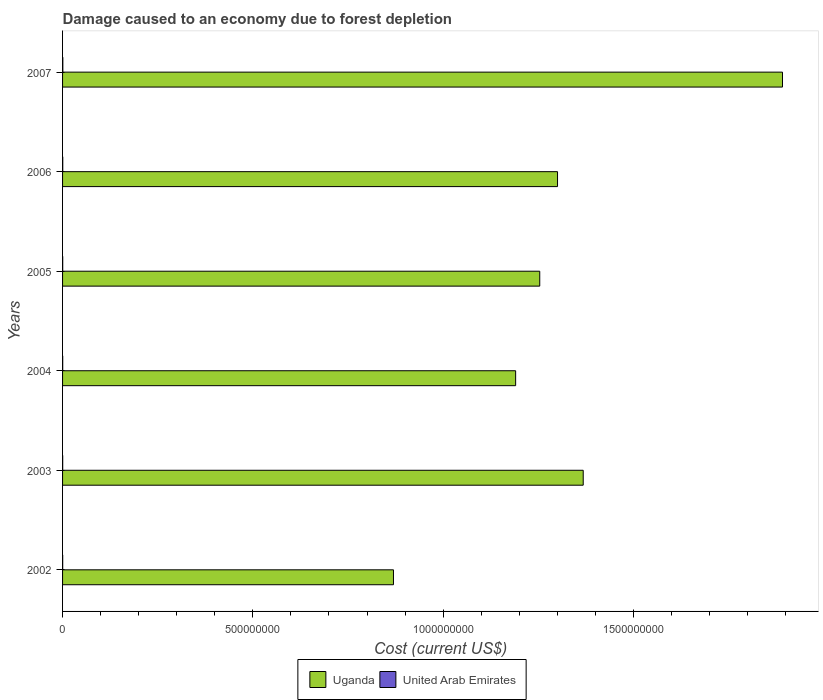How many different coloured bars are there?
Provide a succinct answer. 2. Are the number of bars per tick equal to the number of legend labels?
Keep it short and to the point. Yes. How many bars are there on the 6th tick from the bottom?
Offer a very short reply. 2. What is the label of the 6th group of bars from the top?
Keep it short and to the point. 2002. In how many cases, is the number of bars for a given year not equal to the number of legend labels?
Provide a short and direct response. 0. What is the cost of damage caused due to forest depletion in Uganda in 2005?
Your response must be concise. 1.25e+09. Across all years, what is the maximum cost of damage caused due to forest depletion in United Arab Emirates?
Ensure brevity in your answer.  6.81e+05. Across all years, what is the minimum cost of damage caused due to forest depletion in United Arab Emirates?
Your response must be concise. 3.08e+05. In which year was the cost of damage caused due to forest depletion in Uganda minimum?
Offer a terse response. 2002. What is the total cost of damage caused due to forest depletion in United Arab Emirates in the graph?
Provide a short and direct response. 2.56e+06. What is the difference between the cost of damage caused due to forest depletion in Uganda in 2003 and that in 2007?
Provide a succinct answer. -5.24e+08. What is the difference between the cost of damage caused due to forest depletion in United Arab Emirates in 2006 and the cost of damage caused due to forest depletion in Uganda in 2005?
Offer a very short reply. -1.25e+09. What is the average cost of damage caused due to forest depletion in Uganda per year?
Ensure brevity in your answer.  1.31e+09. In the year 2002, what is the difference between the cost of damage caused due to forest depletion in Uganda and cost of damage caused due to forest depletion in United Arab Emirates?
Make the answer very short. 8.69e+08. What is the ratio of the cost of damage caused due to forest depletion in United Arab Emirates in 2005 to that in 2007?
Offer a terse response. 0.56. Is the difference between the cost of damage caused due to forest depletion in Uganda in 2006 and 2007 greater than the difference between the cost of damage caused due to forest depletion in United Arab Emirates in 2006 and 2007?
Offer a terse response. No. What is the difference between the highest and the second highest cost of damage caused due to forest depletion in United Arab Emirates?
Give a very brief answer. 1.92e+05. What is the difference between the highest and the lowest cost of damage caused due to forest depletion in Uganda?
Your answer should be very brief. 1.02e+09. In how many years, is the cost of damage caused due to forest depletion in United Arab Emirates greater than the average cost of damage caused due to forest depletion in United Arab Emirates taken over all years?
Your answer should be compact. 2. Is the sum of the cost of damage caused due to forest depletion in United Arab Emirates in 2002 and 2006 greater than the maximum cost of damage caused due to forest depletion in Uganda across all years?
Your response must be concise. No. What does the 1st bar from the top in 2006 represents?
Offer a terse response. United Arab Emirates. What does the 1st bar from the bottom in 2002 represents?
Make the answer very short. Uganda. Are all the bars in the graph horizontal?
Provide a short and direct response. Yes. How many years are there in the graph?
Your answer should be very brief. 6. What is the difference between two consecutive major ticks on the X-axis?
Make the answer very short. 5.00e+08. Where does the legend appear in the graph?
Your answer should be compact. Bottom center. How many legend labels are there?
Your answer should be compact. 2. How are the legend labels stacked?
Offer a very short reply. Horizontal. What is the title of the graph?
Your response must be concise. Damage caused to an economy due to forest depletion. Does "Bolivia" appear as one of the legend labels in the graph?
Offer a terse response. No. What is the label or title of the X-axis?
Your answer should be very brief. Cost (current US$). What is the Cost (current US$) in Uganda in 2002?
Your response must be concise. 8.69e+08. What is the Cost (current US$) in United Arab Emirates in 2002?
Provide a short and direct response. 3.08e+05. What is the Cost (current US$) in Uganda in 2003?
Provide a short and direct response. 1.37e+09. What is the Cost (current US$) of United Arab Emirates in 2003?
Keep it short and to the point. 3.32e+05. What is the Cost (current US$) in Uganda in 2004?
Give a very brief answer. 1.19e+09. What is the Cost (current US$) of United Arab Emirates in 2004?
Make the answer very short. 3.74e+05. What is the Cost (current US$) of Uganda in 2005?
Offer a very short reply. 1.25e+09. What is the Cost (current US$) of United Arab Emirates in 2005?
Ensure brevity in your answer.  3.78e+05. What is the Cost (current US$) in Uganda in 2006?
Ensure brevity in your answer.  1.30e+09. What is the Cost (current US$) in United Arab Emirates in 2006?
Provide a succinct answer. 4.89e+05. What is the Cost (current US$) in Uganda in 2007?
Give a very brief answer. 1.89e+09. What is the Cost (current US$) of United Arab Emirates in 2007?
Your answer should be compact. 6.81e+05. Across all years, what is the maximum Cost (current US$) in Uganda?
Give a very brief answer. 1.89e+09. Across all years, what is the maximum Cost (current US$) of United Arab Emirates?
Provide a short and direct response. 6.81e+05. Across all years, what is the minimum Cost (current US$) of Uganda?
Make the answer very short. 8.69e+08. Across all years, what is the minimum Cost (current US$) in United Arab Emirates?
Your response must be concise. 3.08e+05. What is the total Cost (current US$) of Uganda in the graph?
Your response must be concise. 7.87e+09. What is the total Cost (current US$) of United Arab Emirates in the graph?
Give a very brief answer. 2.56e+06. What is the difference between the Cost (current US$) of Uganda in 2002 and that in 2003?
Your response must be concise. -4.99e+08. What is the difference between the Cost (current US$) of United Arab Emirates in 2002 and that in 2003?
Keep it short and to the point. -2.37e+04. What is the difference between the Cost (current US$) in Uganda in 2002 and that in 2004?
Make the answer very short. -3.21e+08. What is the difference between the Cost (current US$) of United Arab Emirates in 2002 and that in 2004?
Make the answer very short. -6.62e+04. What is the difference between the Cost (current US$) in Uganda in 2002 and that in 2005?
Provide a succinct answer. -3.84e+08. What is the difference between the Cost (current US$) of United Arab Emirates in 2002 and that in 2005?
Keep it short and to the point. -6.98e+04. What is the difference between the Cost (current US$) of Uganda in 2002 and that in 2006?
Ensure brevity in your answer.  -4.31e+08. What is the difference between the Cost (current US$) of United Arab Emirates in 2002 and that in 2006?
Keep it short and to the point. -1.81e+05. What is the difference between the Cost (current US$) of Uganda in 2002 and that in 2007?
Your response must be concise. -1.02e+09. What is the difference between the Cost (current US$) in United Arab Emirates in 2002 and that in 2007?
Your answer should be very brief. -3.73e+05. What is the difference between the Cost (current US$) of Uganda in 2003 and that in 2004?
Your answer should be compact. 1.78e+08. What is the difference between the Cost (current US$) in United Arab Emirates in 2003 and that in 2004?
Provide a succinct answer. -4.25e+04. What is the difference between the Cost (current US$) in Uganda in 2003 and that in 2005?
Offer a terse response. 1.14e+08. What is the difference between the Cost (current US$) of United Arab Emirates in 2003 and that in 2005?
Give a very brief answer. -4.60e+04. What is the difference between the Cost (current US$) in Uganda in 2003 and that in 2006?
Your answer should be very brief. 6.75e+07. What is the difference between the Cost (current US$) of United Arab Emirates in 2003 and that in 2006?
Make the answer very short. -1.57e+05. What is the difference between the Cost (current US$) of Uganda in 2003 and that in 2007?
Give a very brief answer. -5.24e+08. What is the difference between the Cost (current US$) of United Arab Emirates in 2003 and that in 2007?
Provide a short and direct response. -3.49e+05. What is the difference between the Cost (current US$) of Uganda in 2004 and that in 2005?
Your answer should be compact. -6.34e+07. What is the difference between the Cost (current US$) of United Arab Emirates in 2004 and that in 2005?
Provide a short and direct response. -3575.79. What is the difference between the Cost (current US$) in Uganda in 2004 and that in 2006?
Your response must be concise. -1.10e+08. What is the difference between the Cost (current US$) in United Arab Emirates in 2004 and that in 2006?
Your answer should be compact. -1.15e+05. What is the difference between the Cost (current US$) in Uganda in 2004 and that in 2007?
Your answer should be very brief. -7.01e+08. What is the difference between the Cost (current US$) of United Arab Emirates in 2004 and that in 2007?
Offer a very short reply. -3.06e+05. What is the difference between the Cost (current US$) in Uganda in 2005 and that in 2006?
Keep it short and to the point. -4.67e+07. What is the difference between the Cost (current US$) in United Arab Emirates in 2005 and that in 2006?
Offer a very short reply. -1.11e+05. What is the difference between the Cost (current US$) in Uganda in 2005 and that in 2007?
Make the answer very short. -6.38e+08. What is the difference between the Cost (current US$) in United Arab Emirates in 2005 and that in 2007?
Your response must be concise. -3.03e+05. What is the difference between the Cost (current US$) in Uganda in 2006 and that in 2007?
Give a very brief answer. -5.91e+08. What is the difference between the Cost (current US$) of United Arab Emirates in 2006 and that in 2007?
Give a very brief answer. -1.92e+05. What is the difference between the Cost (current US$) of Uganda in 2002 and the Cost (current US$) of United Arab Emirates in 2003?
Your answer should be very brief. 8.69e+08. What is the difference between the Cost (current US$) in Uganda in 2002 and the Cost (current US$) in United Arab Emirates in 2004?
Make the answer very short. 8.69e+08. What is the difference between the Cost (current US$) in Uganda in 2002 and the Cost (current US$) in United Arab Emirates in 2005?
Your answer should be compact. 8.69e+08. What is the difference between the Cost (current US$) of Uganda in 2002 and the Cost (current US$) of United Arab Emirates in 2006?
Ensure brevity in your answer.  8.69e+08. What is the difference between the Cost (current US$) of Uganda in 2002 and the Cost (current US$) of United Arab Emirates in 2007?
Give a very brief answer. 8.69e+08. What is the difference between the Cost (current US$) of Uganda in 2003 and the Cost (current US$) of United Arab Emirates in 2004?
Offer a terse response. 1.37e+09. What is the difference between the Cost (current US$) of Uganda in 2003 and the Cost (current US$) of United Arab Emirates in 2005?
Keep it short and to the point. 1.37e+09. What is the difference between the Cost (current US$) in Uganda in 2003 and the Cost (current US$) in United Arab Emirates in 2006?
Your answer should be very brief. 1.37e+09. What is the difference between the Cost (current US$) in Uganda in 2003 and the Cost (current US$) in United Arab Emirates in 2007?
Your answer should be very brief. 1.37e+09. What is the difference between the Cost (current US$) in Uganda in 2004 and the Cost (current US$) in United Arab Emirates in 2005?
Give a very brief answer. 1.19e+09. What is the difference between the Cost (current US$) in Uganda in 2004 and the Cost (current US$) in United Arab Emirates in 2006?
Your response must be concise. 1.19e+09. What is the difference between the Cost (current US$) in Uganda in 2004 and the Cost (current US$) in United Arab Emirates in 2007?
Ensure brevity in your answer.  1.19e+09. What is the difference between the Cost (current US$) in Uganda in 2005 and the Cost (current US$) in United Arab Emirates in 2006?
Offer a very short reply. 1.25e+09. What is the difference between the Cost (current US$) in Uganda in 2005 and the Cost (current US$) in United Arab Emirates in 2007?
Your answer should be compact. 1.25e+09. What is the difference between the Cost (current US$) in Uganda in 2006 and the Cost (current US$) in United Arab Emirates in 2007?
Provide a succinct answer. 1.30e+09. What is the average Cost (current US$) of Uganda per year?
Offer a terse response. 1.31e+09. What is the average Cost (current US$) in United Arab Emirates per year?
Ensure brevity in your answer.  4.27e+05. In the year 2002, what is the difference between the Cost (current US$) of Uganda and Cost (current US$) of United Arab Emirates?
Ensure brevity in your answer.  8.69e+08. In the year 2003, what is the difference between the Cost (current US$) in Uganda and Cost (current US$) in United Arab Emirates?
Your answer should be very brief. 1.37e+09. In the year 2004, what is the difference between the Cost (current US$) of Uganda and Cost (current US$) of United Arab Emirates?
Offer a very short reply. 1.19e+09. In the year 2005, what is the difference between the Cost (current US$) of Uganda and Cost (current US$) of United Arab Emirates?
Your response must be concise. 1.25e+09. In the year 2006, what is the difference between the Cost (current US$) in Uganda and Cost (current US$) in United Arab Emirates?
Your response must be concise. 1.30e+09. In the year 2007, what is the difference between the Cost (current US$) of Uganda and Cost (current US$) of United Arab Emirates?
Offer a very short reply. 1.89e+09. What is the ratio of the Cost (current US$) of Uganda in 2002 to that in 2003?
Your answer should be compact. 0.64. What is the ratio of the Cost (current US$) of United Arab Emirates in 2002 to that in 2003?
Keep it short and to the point. 0.93. What is the ratio of the Cost (current US$) in Uganda in 2002 to that in 2004?
Ensure brevity in your answer.  0.73. What is the ratio of the Cost (current US$) of United Arab Emirates in 2002 to that in 2004?
Give a very brief answer. 0.82. What is the ratio of the Cost (current US$) of Uganda in 2002 to that in 2005?
Provide a short and direct response. 0.69. What is the ratio of the Cost (current US$) in United Arab Emirates in 2002 to that in 2005?
Provide a succinct answer. 0.82. What is the ratio of the Cost (current US$) of Uganda in 2002 to that in 2006?
Offer a very short reply. 0.67. What is the ratio of the Cost (current US$) of United Arab Emirates in 2002 to that in 2006?
Make the answer very short. 0.63. What is the ratio of the Cost (current US$) of Uganda in 2002 to that in 2007?
Offer a very short reply. 0.46. What is the ratio of the Cost (current US$) of United Arab Emirates in 2002 to that in 2007?
Your answer should be very brief. 0.45. What is the ratio of the Cost (current US$) of Uganda in 2003 to that in 2004?
Your response must be concise. 1.15. What is the ratio of the Cost (current US$) of United Arab Emirates in 2003 to that in 2004?
Ensure brevity in your answer.  0.89. What is the ratio of the Cost (current US$) in Uganda in 2003 to that in 2005?
Give a very brief answer. 1.09. What is the ratio of the Cost (current US$) of United Arab Emirates in 2003 to that in 2005?
Keep it short and to the point. 0.88. What is the ratio of the Cost (current US$) in Uganda in 2003 to that in 2006?
Make the answer very short. 1.05. What is the ratio of the Cost (current US$) in United Arab Emirates in 2003 to that in 2006?
Your answer should be compact. 0.68. What is the ratio of the Cost (current US$) of Uganda in 2003 to that in 2007?
Your response must be concise. 0.72. What is the ratio of the Cost (current US$) in United Arab Emirates in 2003 to that in 2007?
Provide a short and direct response. 0.49. What is the ratio of the Cost (current US$) in Uganda in 2004 to that in 2005?
Keep it short and to the point. 0.95. What is the ratio of the Cost (current US$) in United Arab Emirates in 2004 to that in 2005?
Offer a very short reply. 0.99. What is the ratio of the Cost (current US$) of Uganda in 2004 to that in 2006?
Provide a succinct answer. 0.92. What is the ratio of the Cost (current US$) in United Arab Emirates in 2004 to that in 2006?
Give a very brief answer. 0.77. What is the ratio of the Cost (current US$) of Uganda in 2004 to that in 2007?
Your answer should be very brief. 0.63. What is the ratio of the Cost (current US$) in United Arab Emirates in 2004 to that in 2007?
Your response must be concise. 0.55. What is the ratio of the Cost (current US$) of Uganda in 2005 to that in 2006?
Offer a very short reply. 0.96. What is the ratio of the Cost (current US$) in United Arab Emirates in 2005 to that in 2006?
Provide a short and direct response. 0.77. What is the ratio of the Cost (current US$) in Uganda in 2005 to that in 2007?
Offer a very short reply. 0.66. What is the ratio of the Cost (current US$) in United Arab Emirates in 2005 to that in 2007?
Your response must be concise. 0.56. What is the ratio of the Cost (current US$) of Uganda in 2006 to that in 2007?
Keep it short and to the point. 0.69. What is the ratio of the Cost (current US$) of United Arab Emirates in 2006 to that in 2007?
Make the answer very short. 0.72. What is the difference between the highest and the second highest Cost (current US$) of Uganda?
Your answer should be very brief. 5.24e+08. What is the difference between the highest and the second highest Cost (current US$) in United Arab Emirates?
Offer a terse response. 1.92e+05. What is the difference between the highest and the lowest Cost (current US$) in Uganda?
Make the answer very short. 1.02e+09. What is the difference between the highest and the lowest Cost (current US$) of United Arab Emirates?
Ensure brevity in your answer.  3.73e+05. 